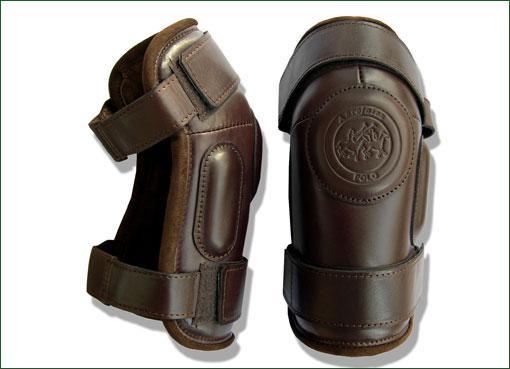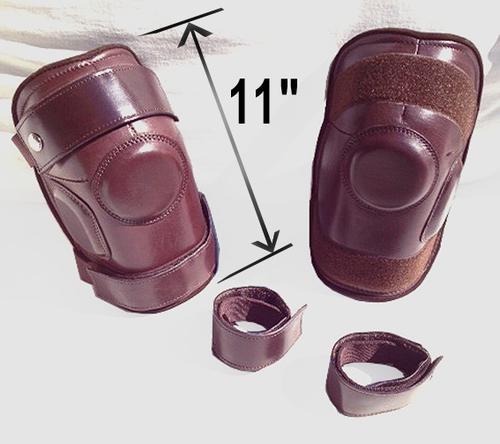The first image is the image on the left, the second image is the image on the right. Examine the images to the left and right. Is the description "The number of protective items are not an even number; it is an odd number." accurate? Answer yes or no. No. 